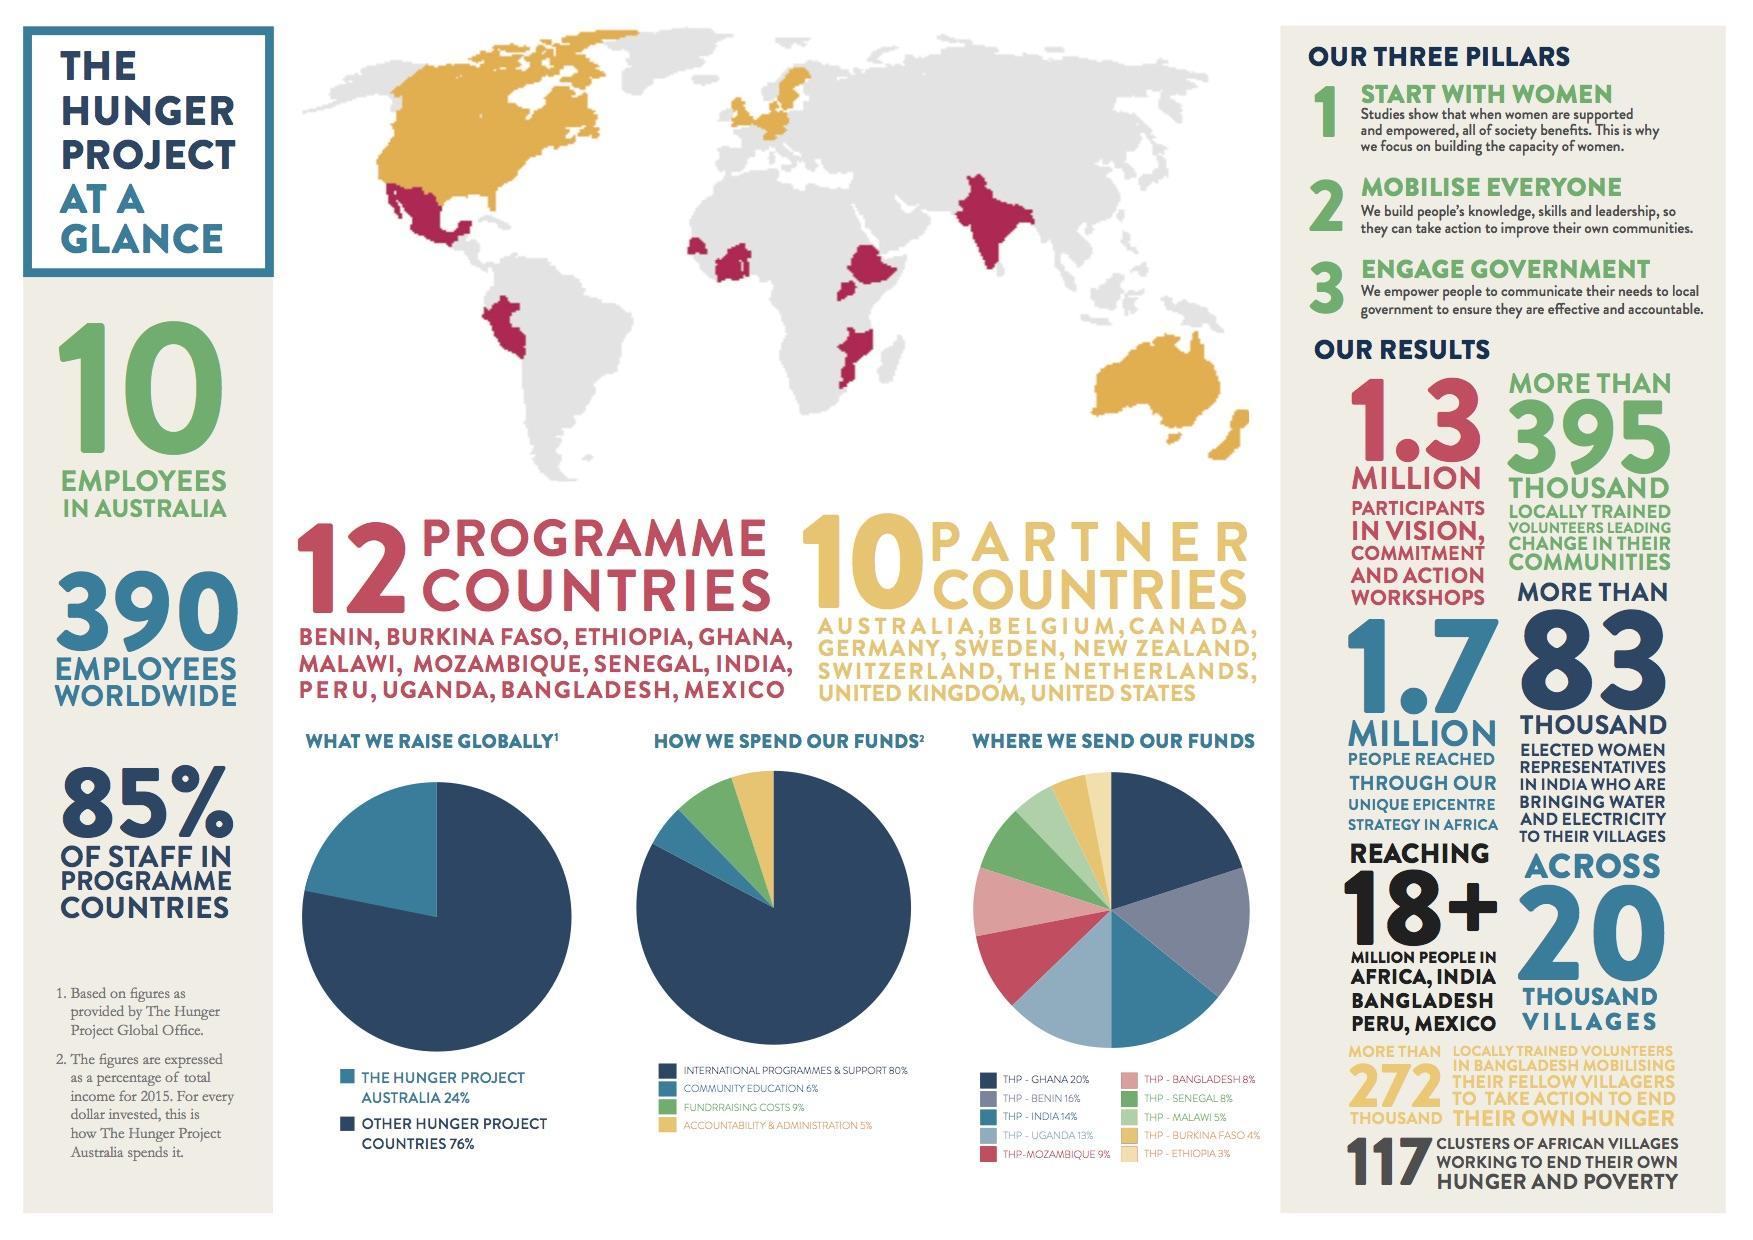Outline some significant characteristics in this image. The institution with the highest share of community education, international programs, and support for international programs is XYZ University. The percentage of community education and fundraising costs, taken together, is 15%. In total, community education and accountability & administration combined make up 11% of the organization's budget. The Hunger Project Australia has the highest share of other Hunger Project countries. 